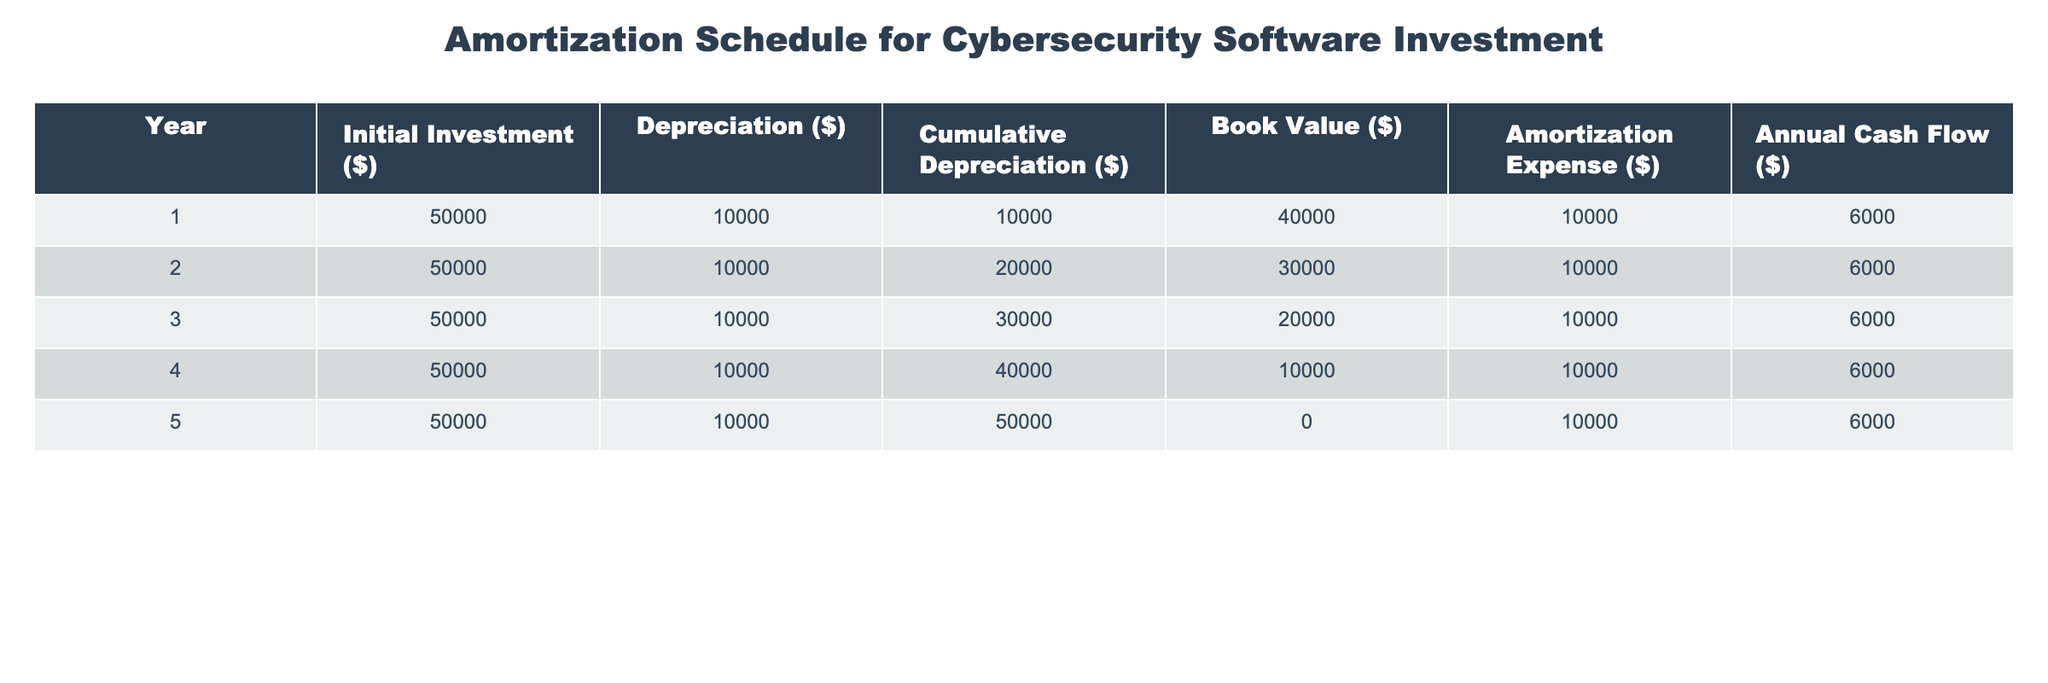What is the initial investment amount for the cybersecurity software? The table shows that the initial investment for each year is consistently $50,000. Therefore, the initial investment amount is $50,000.
Answer: 50000 In which year does the cumulative depreciation first reach $30,000? Looking at the cumulative depreciation column, after Year 3, the cumulative depreciation becomes $30,000. Thus, it first reaches $30,000 in Year 3.
Answer: 3 What is the average annual cash flow across all five years? The annual cash flow values are $6,000 for each year. To find the average, sum these amounts (6,000 * 5) = $30,000 and divide by 5, resulting in an average of $6,000 per year.
Answer: 6000 Does the book value become 0 at any point during the five years? The book value column indicates that the book value is $0 in Year 5, confirming that it does become 0 during this timeframe.
Answer: Yes What is the total amount of amortization expenses over the five years? To find the total amortization expenses, sum the amortization expenses for each year: $10,000 + $10,000 + $10,000 + $10,000 + $10,000 = $50,000.
Answer: 50000 Which year sees the highest cumulative depreciation, and what is that value? The cumulative depreciation increases each year by $10,000. By Year 5, the cumulative depreciation reaches $50,000, which is the highest value.
Answer: 50,000 in Year 5 What is the difference between the total annual cash flow and the total amortization expense after five years? The total annual cash flow is $30,000 while the total amortization expense is $50,000. The difference would be $30,000 - $50,000 = -$20,000 indicating a net outflow of $20,000.
Answer: -20000 Is the amortization expense the same for each year? Yes, the table shows that the amortization expense is consistently $10,000 each year.
Answer: Yes How much has the book value depreciated from Year 1 to Year 4? The book value in Year 1 is $40,000, and in Year 4 it is $10,000. The depreciation in book value is $40,000 - $10,000 = $30,000 from Year 1 to Year 4.
Answer: 30000 